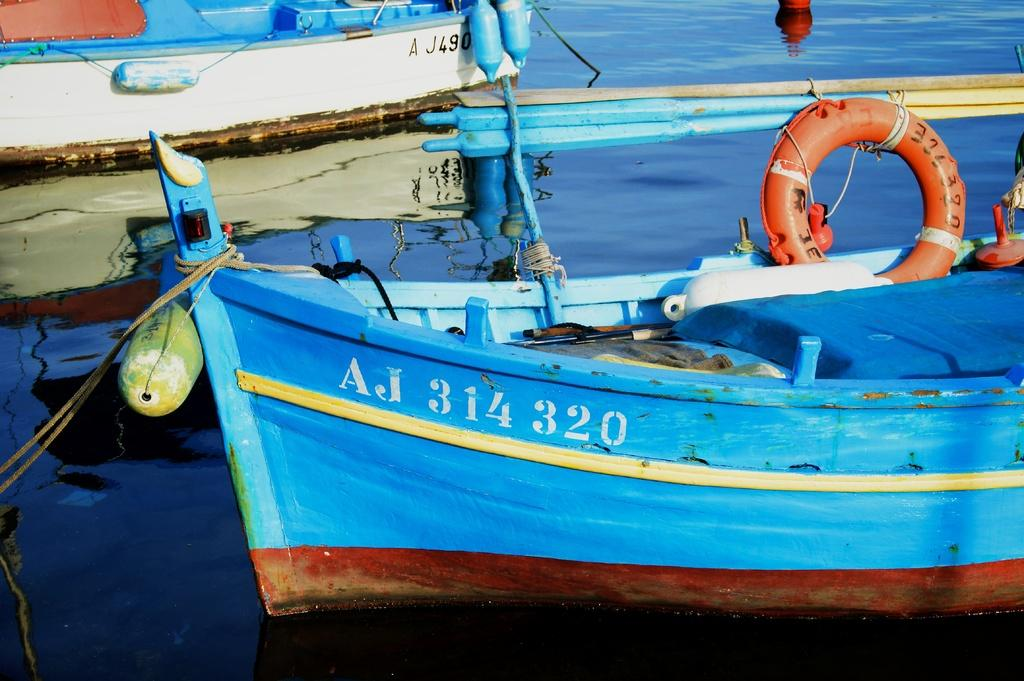<image>
Write a terse but informative summary of the picture. A blue boat sits in the water labeled with the letters and numbers AJ 314 320 in white. 